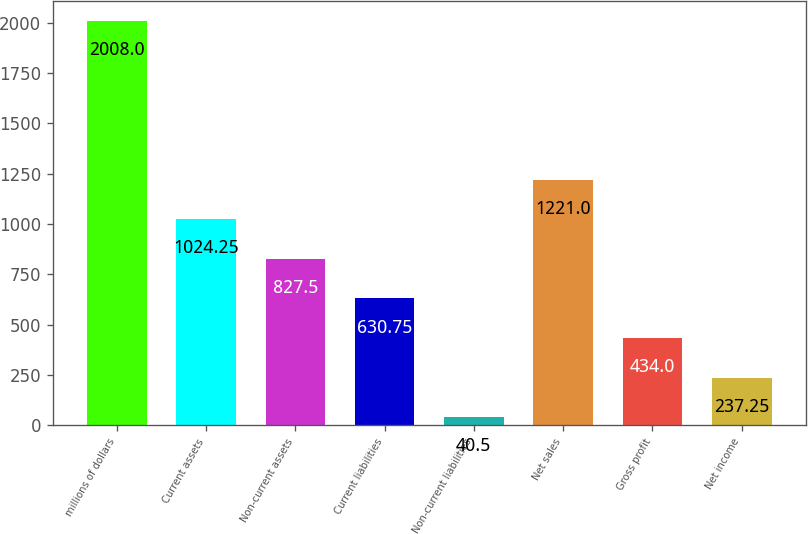<chart> <loc_0><loc_0><loc_500><loc_500><bar_chart><fcel>millions of dollars<fcel>Current assets<fcel>Non-current assets<fcel>Current liabilities<fcel>Non-current liabilities<fcel>Net sales<fcel>Gross profit<fcel>Net income<nl><fcel>2008<fcel>1024.25<fcel>827.5<fcel>630.75<fcel>40.5<fcel>1221<fcel>434<fcel>237.25<nl></chart> 